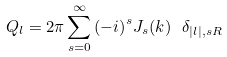<formula> <loc_0><loc_0><loc_500><loc_500>Q _ { l } = 2 \pi \sum _ { s = 0 } ^ { \infty } { ( - i ) } ^ { s } J _ { s } ( k ) \ \delta _ { | l | , s R }</formula> 